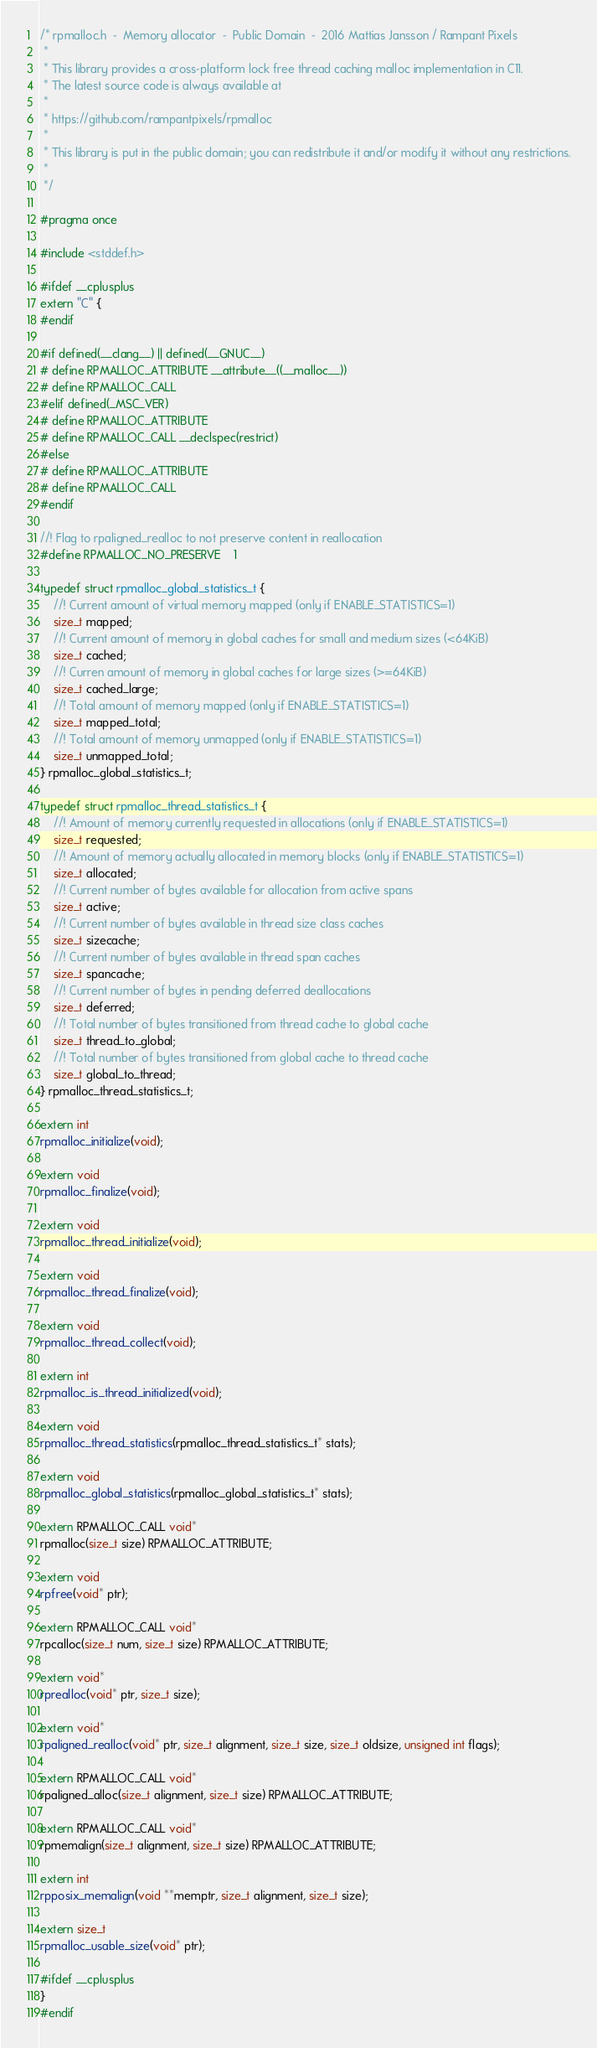Convert code to text. <code><loc_0><loc_0><loc_500><loc_500><_C_>/* rpmalloc.h  -  Memory allocator  -  Public Domain  -  2016 Mattias Jansson / Rampant Pixels
 *
 * This library provides a cross-platform lock free thread caching malloc implementation in C11.
 * The latest source code is always available at
 *
 * https://github.com/rampantpixels/rpmalloc
 *
 * This library is put in the public domain; you can redistribute it and/or modify it without any restrictions.
 *
 */

#pragma once

#include <stddef.h>

#ifdef __cplusplus
extern "C" {
#endif

#if defined(__clang__) || defined(__GNUC__)
# define RPMALLOC_ATTRIBUTE __attribute__((__malloc__))
# define RPMALLOC_CALL
#elif defined(_MSC_VER)
# define RPMALLOC_ATTRIBUTE
# define RPMALLOC_CALL __declspec(restrict)
#else
# define RPMALLOC_ATTRIBUTE
# define RPMALLOC_CALL
#endif

//! Flag to rpaligned_realloc to not preserve content in reallocation
#define RPMALLOC_NO_PRESERVE    1

typedef struct rpmalloc_global_statistics_t {
	//! Current amount of virtual memory mapped (only if ENABLE_STATISTICS=1)
	size_t mapped;
	//! Current amount of memory in global caches for small and medium sizes (<64KiB)
	size_t cached;
	//! Curren amount of memory in global caches for large sizes (>=64KiB)
	size_t cached_large;
	//! Total amount of memory mapped (only if ENABLE_STATISTICS=1)
	size_t mapped_total;
	//! Total amount of memory unmapped (only if ENABLE_STATISTICS=1)
	size_t unmapped_total;
} rpmalloc_global_statistics_t;

typedef struct rpmalloc_thread_statistics_t {
	//! Amount of memory currently requested in allocations (only if ENABLE_STATISTICS=1)
	size_t requested;
	//! Amount of memory actually allocated in memory blocks (only if ENABLE_STATISTICS=1)
	size_t allocated;
	//! Current number of bytes available for allocation from active spans
	size_t active;
	//! Current number of bytes available in thread size class caches
	size_t sizecache;
	//! Current number of bytes available in thread span caches
	size_t spancache;
	//! Current number of bytes in pending deferred deallocations
	size_t deferred;
	//! Total number of bytes transitioned from thread cache to global cache
	size_t thread_to_global;
	//! Total number of bytes transitioned from global cache to thread cache
	size_t global_to_thread;
} rpmalloc_thread_statistics_t;

extern int
rpmalloc_initialize(void);

extern void
rpmalloc_finalize(void);

extern void
rpmalloc_thread_initialize(void);

extern void
rpmalloc_thread_finalize(void);

extern void
rpmalloc_thread_collect(void);

extern int
rpmalloc_is_thread_initialized(void);

extern void
rpmalloc_thread_statistics(rpmalloc_thread_statistics_t* stats);

extern void
rpmalloc_global_statistics(rpmalloc_global_statistics_t* stats);

extern RPMALLOC_CALL void*
rpmalloc(size_t size) RPMALLOC_ATTRIBUTE;

extern void
rpfree(void* ptr);

extern RPMALLOC_CALL void*
rpcalloc(size_t num, size_t size) RPMALLOC_ATTRIBUTE;

extern void*
rprealloc(void* ptr, size_t size);

extern void*
rpaligned_realloc(void* ptr, size_t alignment, size_t size, size_t oldsize, unsigned int flags);

extern RPMALLOC_CALL void*
rpaligned_alloc(size_t alignment, size_t size) RPMALLOC_ATTRIBUTE;

extern RPMALLOC_CALL void*
rpmemalign(size_t alignment, size_t size) RPMALLOC_ATTRIBUTE;

extern int
rpposix_memalign(void **memptr, size_t alignment, size_t size);

extern size_t
rpmalloc_usable_size(void* ptr);

#ifdef __cplusplus
}
#endif
</code> 